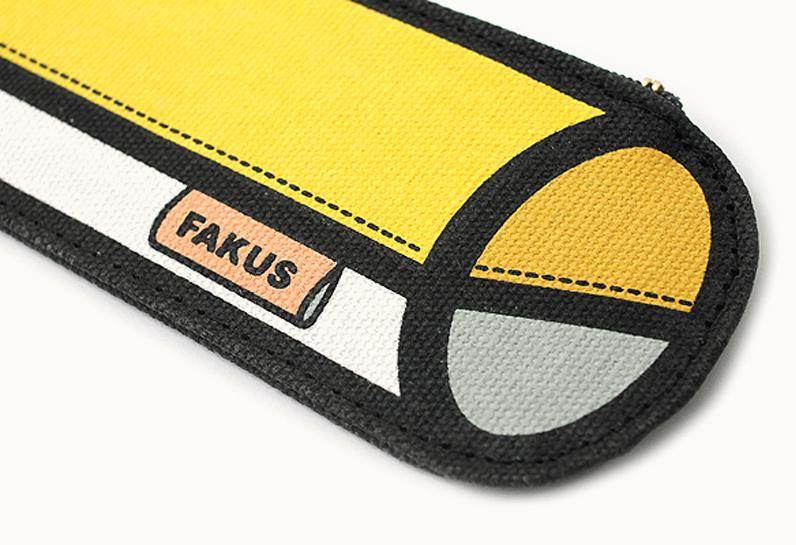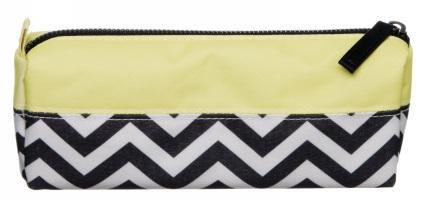The first image is the image on the left, the second image is the image on the right. Assess this claim about the two images: "for the image on the right side, the bag has black and white zigzags.". Correct or not? Answer yes or no. Yes. 